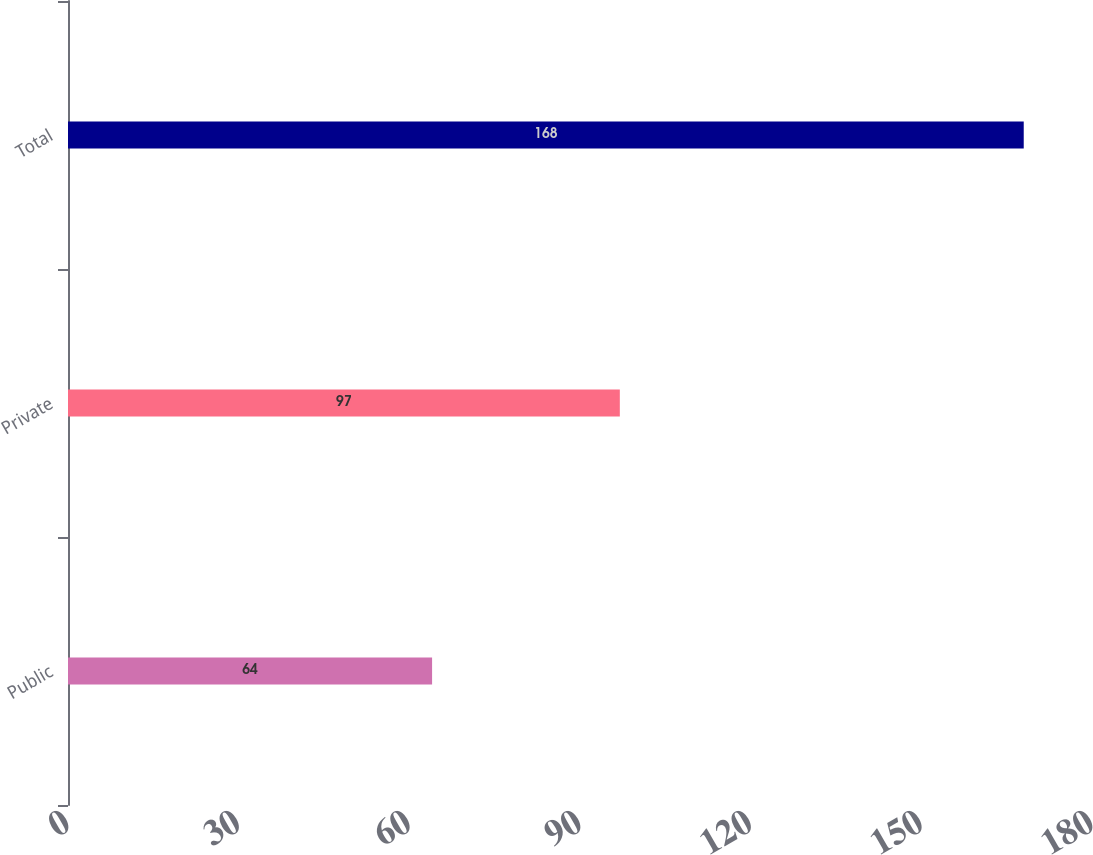Convert chart. <chart><loc_0><loc_0><loc_500><loc_500><bar_chart><fcel>Public<fcel>Private<fcel>Total<nl><fcel>64<fcel>97<fcel>168<nl></chart> 